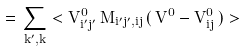<formula> <loc_0><loc_0><loc_500><loc_500>= \, \sum _ { k ^ { \prime } , k } < V ^ { 0 } _ { i ^ { \prime } j ^ { \prime } } \, M _ { i ^ { \prime } j ^ { \prime } , i j } \, ( \, V ^ { 0 } - V ^ { 0 } _ { i j } \, ) ></formula> 